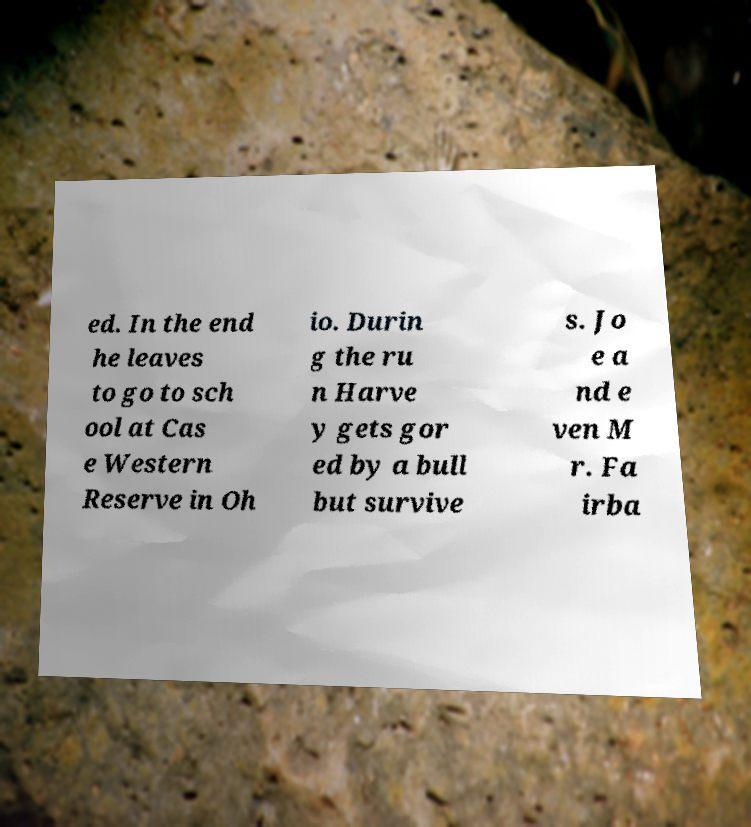Could you assist in decoding the text presented in this image and type it out clearly? ed. In the end he leaves to go to sch ool at Cas e Western Reserve in Oh io. Durin g the ru n Harve y gets gor ed by a bull but survive s. Jo e a nd e ven M r. Fa irba 